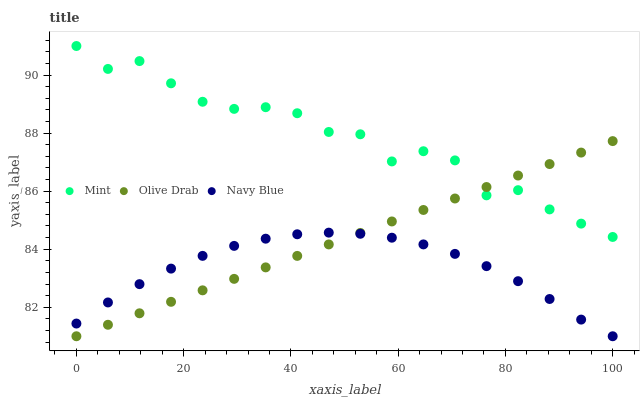Does Navy Blue have the minimum area under the curve?
Answer yes or no. Yes. Does Mint have the maximum area under the curve?
Answer yes or no. Yes. Does Olive Drab have the minimum area under the curve?
Answer yes or no. No. Does Olive Drab have the maximum area under the curve?
Answer yes or no. No. Is Olive Drab the smoothest?
Answer yes or no. Yes. Is Mint the roughest?
Answer yes or no. Yes. Is Mint the smoothest?
Answer yes or no. No. Is Olive Drab the roughest?
Answer yes or no. No. Does Navy Blue have the lowest value?
Answer yes or no. Yes. Does Mint have the lowest value?
Answer yes or no. No. Does Mint have the highest value?
Answer yes or no. Yes. Does Olive Drab have the highest value?
Answer yes or no. No. Is Navy Blue less than Mint?
Answer yes or no. Yes. Is Mint greater than Navy Blue?
Answer yes or no. Yes. Does Mint intersect Olive Drab?
Answer yes or no. Yes. Is Mint less than Olive Drab?
Answer yes or no. No. Is Mint greater than Olive Drab?
Answer yes or no. No. Does Navy Blue intersect Mint?
Answer yes or no. No. 